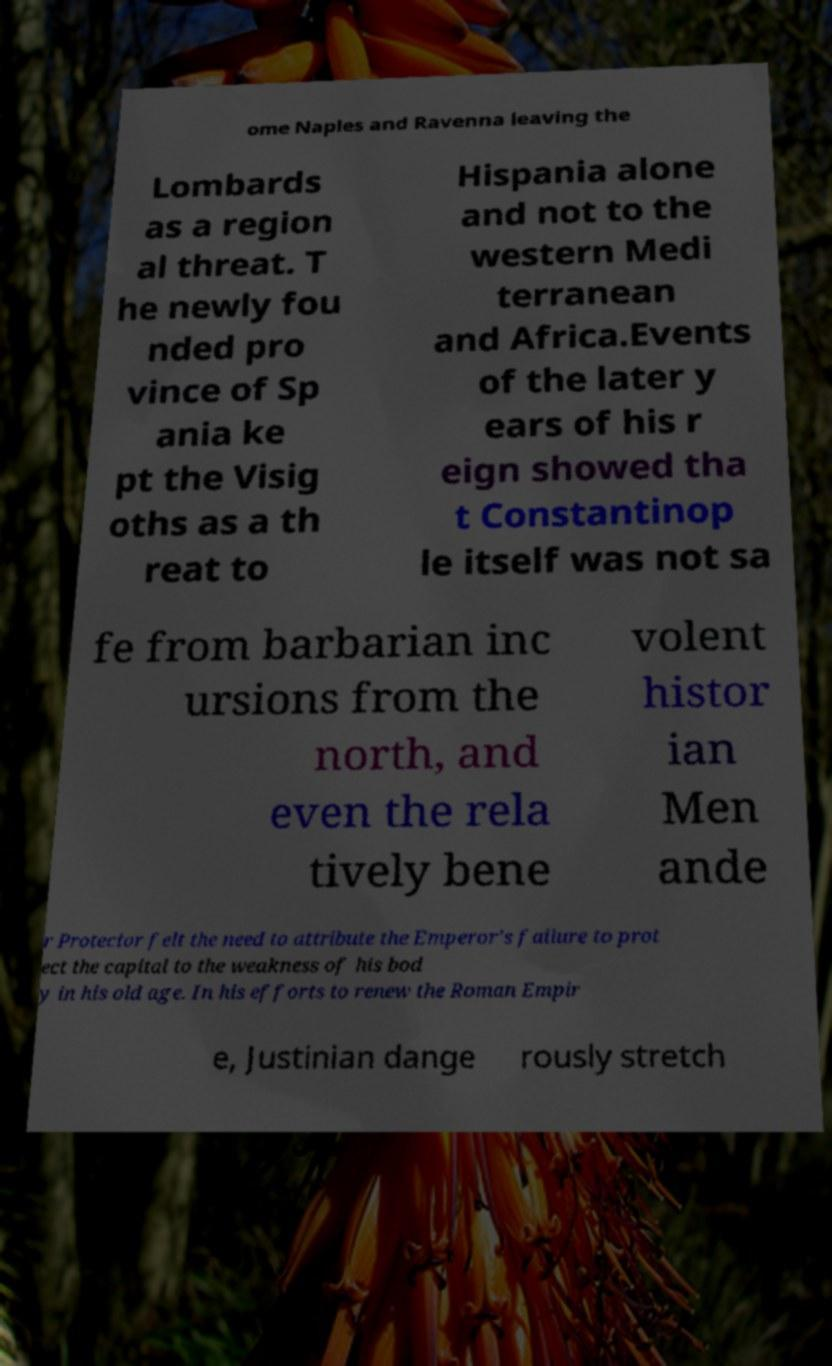Could you assist in decoding the text presented in this image and type it out clearly? ome Naples and Ravenna leaving the Lombards as a region al threat. T he newly fou nded pro vince of Sp ania ke pt the Visig oths as a th reat to Hispania alone and not to the western Medi terranean and Africa.Events of the later y ears of his r eign showed tha t Constantinop le itself was not sa fe from barbarian inc ursions from the north, and even the rela tively bene volent histor ian Men ande r Protector felt the need to attribute the Emperor's failure to prot ect the capital to the weakness of his bod y in his old age. In his efforts to renew the Roman Empir e, Justinian dange rously stretch 